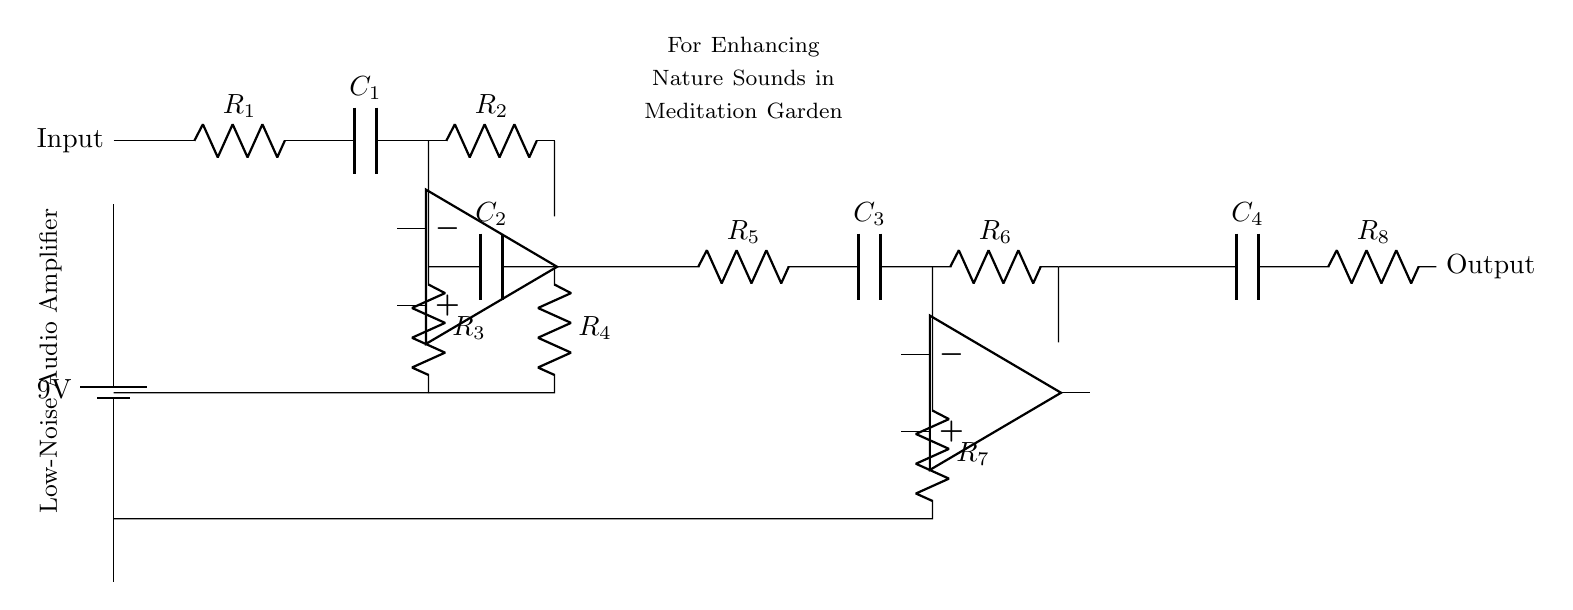What is the combined capacitance of C1, C2, C3, and C4? To find the combined capacitance, we notice that C1, C2, C3, and C4 are connected in different stages of the circuit. If they are considered in series and parallel combinations, additional information about their individual values would be required to calculate the exact total. Without specific values provided, we cannot calculate an exact number here.
Answer: Not determinable What is the role of the op-amps in this circuit? The operational amplifiers (op-amps) in the circuit are used to amplify the audio signal while maintaining a low noise level. They perform the essential function of increasing the strength of the weak nature sound signals received at the input. This allows for clearer audio output suitable for the meditation garden.
Answer: Amplification How many resistors are in the circuit? There are a total of six resistors indicated in the circuit diagram by their symbols (R1, R2, R3, R4, R5, R6, R7, R8). Counting all the indicated resistors, we see there are eight.
Answer: Eight What is the input of this amplifier circuit? The input comes from the left side of the circuit, as represented by the "Input" label. This is where external audio signals (like nature sounds) are connected to be processed by the amplifier.
Answer: External audio signals What is the power supply voltage in this circuit? The power supply is labeled with a voltage of 9V connected at the bottom of the circuit. This indicates that the circuit operates with a supply voltage of 9 volts.
Answer: Nine volts Which capacitors are used in the circuit? The circuit includes four capacitors labeled as C1, C2, C3, and C4, which are used for various coupling and filtering purposes to enhance audio quality and reduce noise.
Answer: C1, C2, C3, C4 